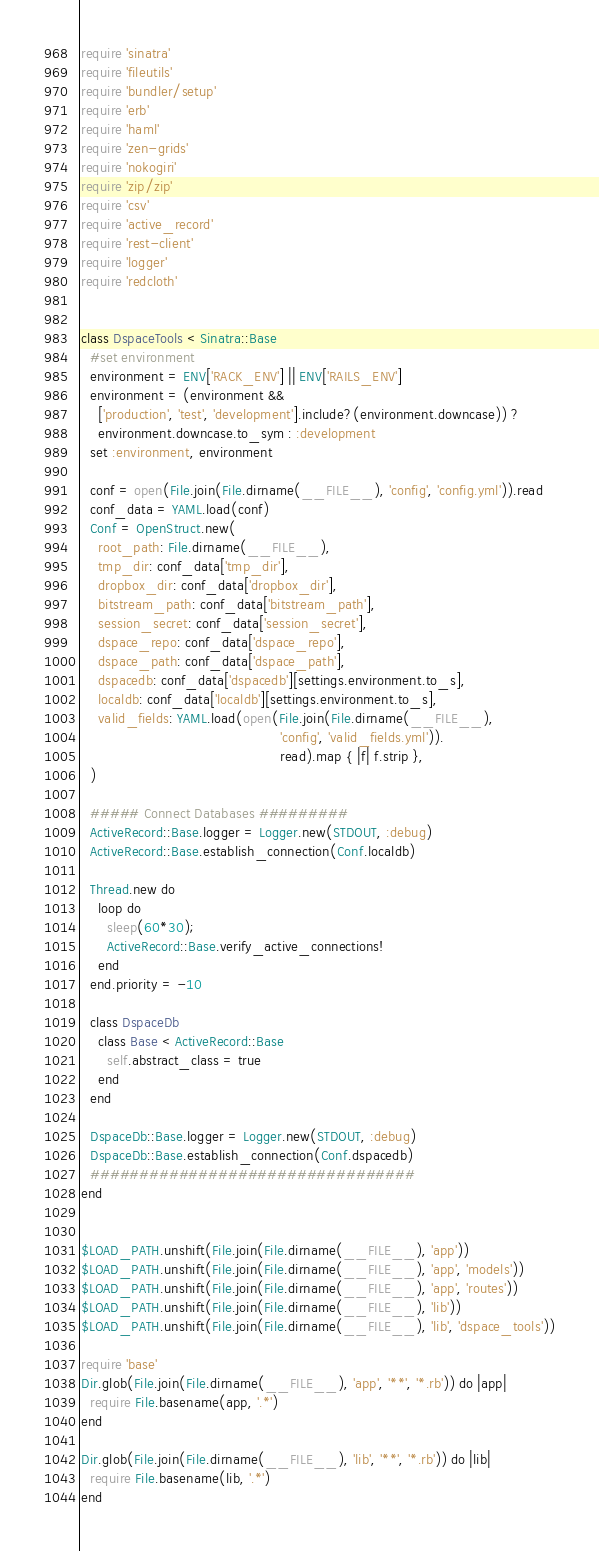Convert code to text. <code><loc_0><loc_0><loc_500><loc_500><_Ruby_>require 'sinatra'
require 'fileutils'
require 'bundler/setup'
require 'erb'
require 'haml'
require 'zen-grids'
require 'nokogiri'
require 'zip/zip'
require 'csv'
require 'active_record'
require 'rest-client'
require 'logger'
require 'redcloth'


class DspaceTools < Sinatra::Base
  #set environment
  environment = ENV['RACK_ENV'] || ENV['RAILS_ENV']
  environment = (environment &&
    ['production', 'test', 'development'].include?(environment.downcase)) ?
    environment.downcase.to_sym : :development
  set :environment, environment

  conf = open(File.join(File.dirname(__FILE__), 'config', 'config.yml')).read
  conf_data = YAML.load(conf)
  Conf = OpenStruct.new(
    root_path: File.dirname(__FILE__),
    tmp_dir: conf_data['tmp_dir'],
    dropbox_dir: conf_data['dropbox_dir'],
    bitstream_path: conf_data['bitstream_path'],
    session_secret: conf_data['session_secret'],
    dspace_repo: conf_data['dspace_repo'],
    dspace_path: conf_data['dspace_path'],
    dspacedb: conf_data['dspacedb'][settings.environment.to_s],
    localdb: conf_data['localdb'][settings.environment.to_s],
    valid_fields: YAML.load(open(File.join(File.dirname(__FILE__),
                                              'config', 'valid_fields.yml')).
                                              read).map { |f| f.strip },
  )

  ##### Connect Databases #########
  ActiveRecord::Base.logger = Logger.new(STDOUT, :debug)
  ActiveRecord::Base.establish_connection(Conf.localdb)

  Thread.new do
    loop do
      sleep(60*30);
      ActiveRecord::Base.verify_active_connections!
    end
  end.priority = -10

  class DspaceDb
    class Base < ActiveRecord::Base
      self.abstract_class = true
    end
  end

  DspaceDb::Base.logger = Logger.new(STDOUT, :debug)
  DspaceDb::Base.establish_connection(Conf.dspacedb)
  #################################
end


$LOAD_PATH.unshift(File.join(File.dirname(__FILE__), 'app'))
$LOAD_PATH.unshift(File.join(File.dirname(__FILE__), 'app', 'models'))
$LOAD_PATH.unshift(File.join(File.dirname(__FILE__), 'app', 'routes'))
$LOAD_PATH.unshift(File.join(File.dirname(__FILE__), 'lib'))
$LOAD_PATH.unshift(File.join(File.dirname(__FILE__), 'lib', 'dspace_tools'))

require 'base'
Dir.glob(File.join(File.dirname(__FILE__), 'app', '**', '*.rb')) do |app|
  require File.basename(app, '.*')
end

Dir.glob(File.join(File.dirname(__FILE__), 'lib', '**', '*.rb')) do |lib|
  require File.basename(lib, '.*')
end
</code> 